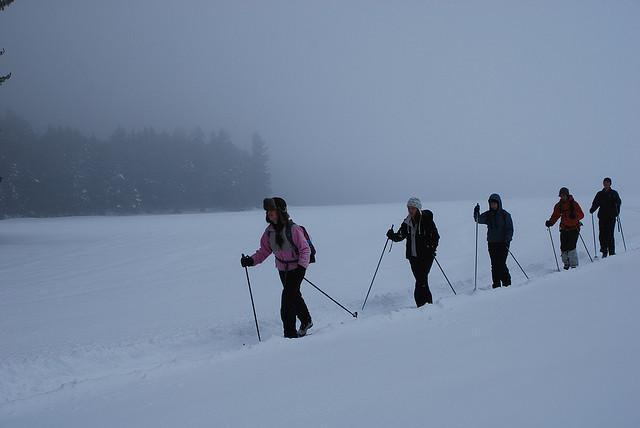How many people are in this group?
Give a very brief answer. 5. How many people are actually in the photo?
Give a very brief answer. 5. How many people are there?
Give a very brief answer. 5. How many people are wearing white hats?
Give a very brief answer. 1. How many people can you see?
Give a very brief answer. 3. How many yellow cups are in the image?
Give a very brief answer. 0. 